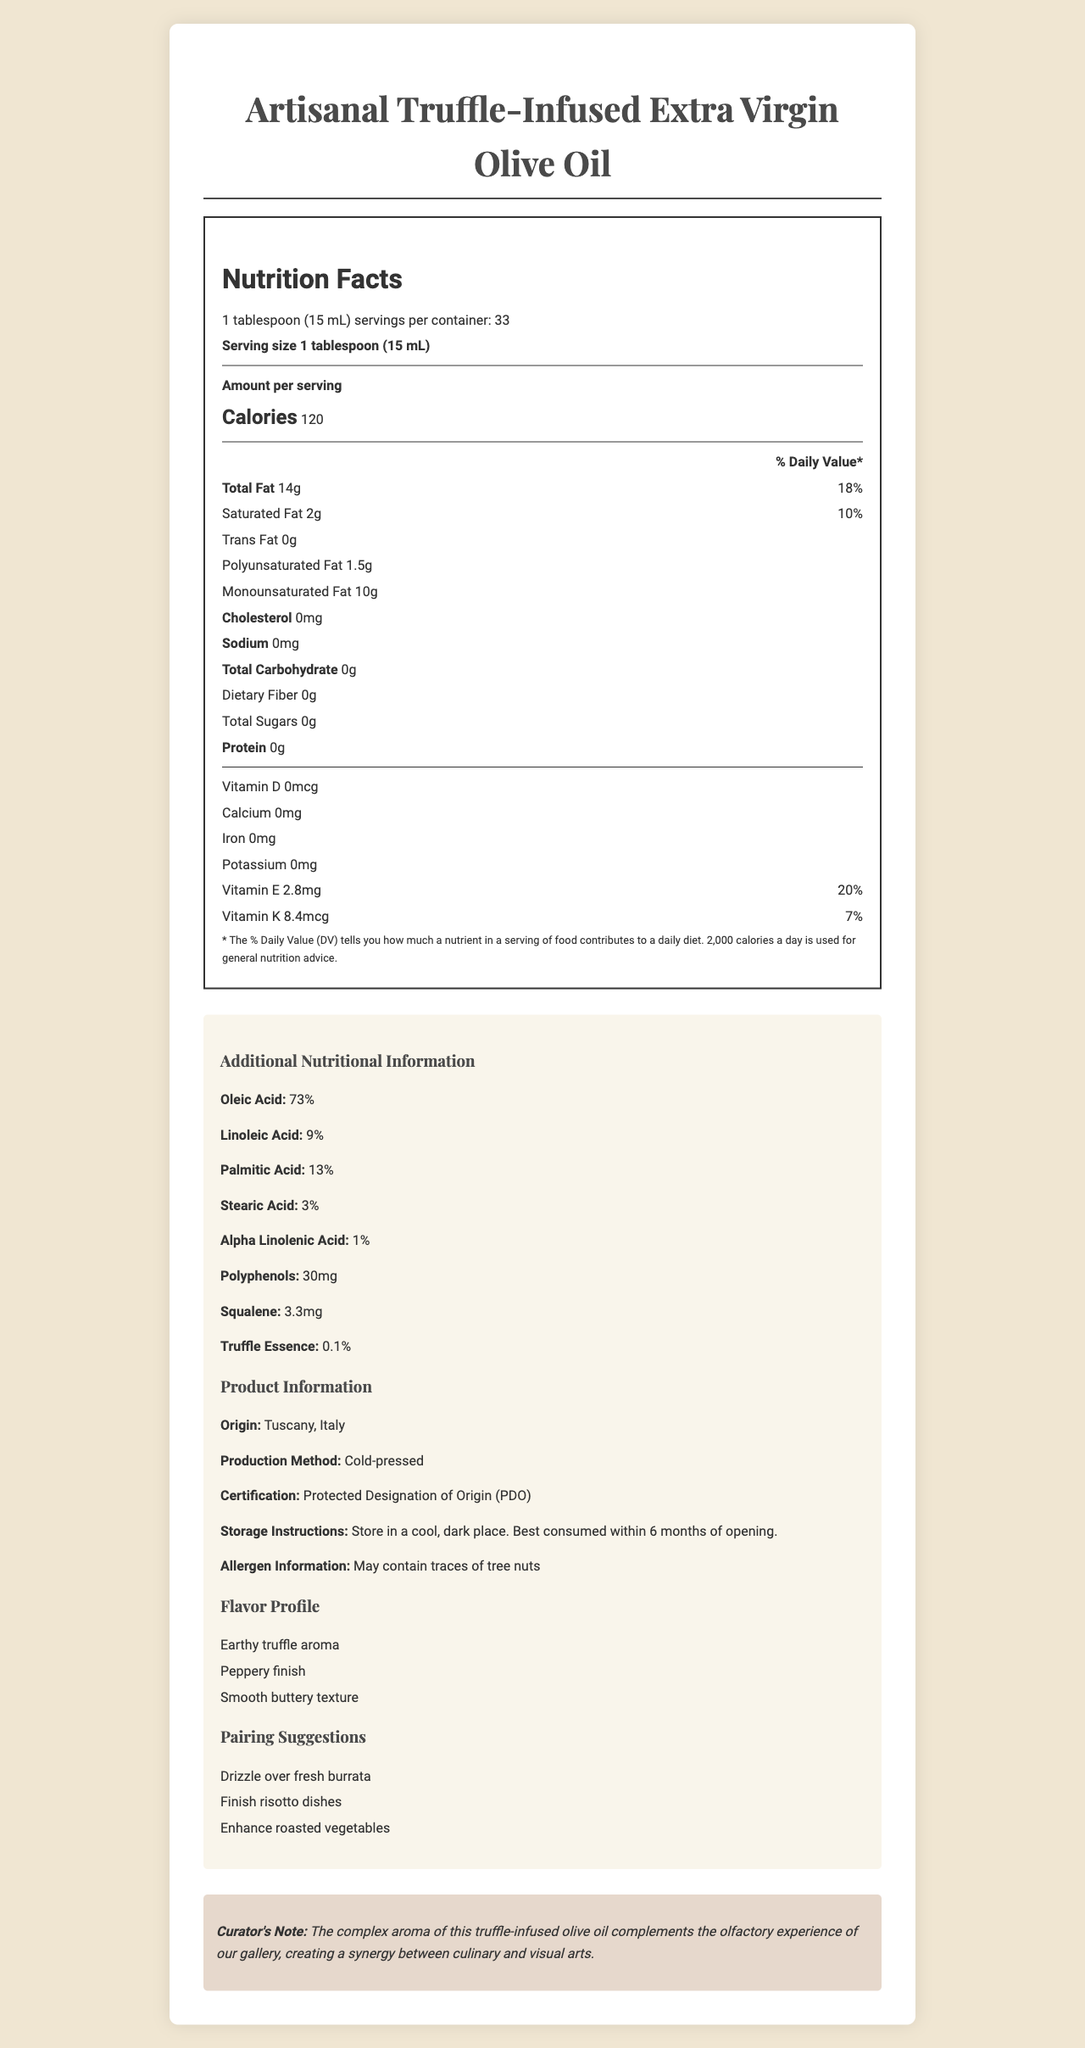what is the serving size of the truffle-infused olive oil? The serving size is stated at the beginning of the Nutrition Facts as "1 tablespoon (15 mL)".
Answer: 1 tablespoon (15 mL) how many calories are in one serving? The document specifies "Amount per serving" and lists "Calories 120".
Answer: 120 what percentage of the daily value is the saturated fat content? Under the "Total Fat" section, it is stated that the Saturated Fat is 2g, with a daily value of 10%.
Answer: 10% how much Vitamin E is in one serving? The Vitamin E content is listed as "2.8mg" with a daily value of "20%".
Answer: 2.8mg what is the origin of the truffle-infused olive oil? The additional information section mentions that the origin is "Tuscany, Italy".
Answer: Tuscany, Italy which type of fatty acid is present in the largest amount? A. Oleic Acid B. Linoleic Acid C. Palmitic Acid D. Stearic Acid Oleic Acid is listed at 73%, which is higher than Linoleic Acid (9%), Palmitic Acid (13%), and Stearic Acid (3%).
Answer: A what is the daily value of sodium in one serving? A. 0% B. 5% C. 10% D. 15% Sodium is listed as 0mg, which implies a 0% daily value.
Answer: A is there any cholesterol in the truffle-infused olive oil? The document lists cholesterol as "0mg".
Answer: No what are the pairing suggestions provided for the truffle-infused olive oil? These suggestions are listed in the "Pairing Suggestions" section.
Answer: Drizzle over fresh burrata, Finish risotto dishes, Enhance roasted vegetables summarize the main idea of the document. The document comprehensively covers the nutritional aspects and unique features of the olive oil while also providing practical usage and storage tips.
Answer: The document provides detailed nutritional information about Artisanal Truffle-Infused Extra Virgin Olive Oil, highlighting its fatty acid profile, vitamins, origin, production method, and pairing suggestions. It also includes flavor notes, storage instructions, and a curator's note on how it complements the gallery's ambiance. who certified the truffle-infused olive oil? The certification is listed as "Protected Designation of Origin (PDO)" under the additional product information.
Answer: PDO (Protected Designation of Origin) what are the polyphenol and squalene contents in the olive oil? Both are listed under the additional nutritional information section with their respective amounts.
Answer: Polyphenols: 30mg, Squalene: 3.3mg describe the flavor profile of this truffle-infused olive oil. The flavor notes provided are "Earthy truffle aroma", "Peppery finish", and "Smooth buttery texture".
Answer: Earthy truffle aroma, Peppery finish, Smooth buttery texture how many carbs are in one serving? The total carbohydrate content is listed as "0g".
Answer: 0g what makes the truffle-infused olive oil complementary to the gallery's ambiance? The curator's note explains how the aroma enhances the gallery experience.
Answer: The complex aroma of the truffle-infused olive oil complements the olfactory experience of the gallery, creating a synergy between culinary and visual arts. can you find information about the vitamin C content in the document? The document does not mention vitamin C content.
Answer: Not enough information is the production method of the olive oil specified as cold-pressed? The production method is listed as "Cold-pressed".
Answer: Yes what is the specific content percentage of truffle essence in the olive oil? The document mentions that the truffle essence content is "0.1%".
Answer: 0.1% 